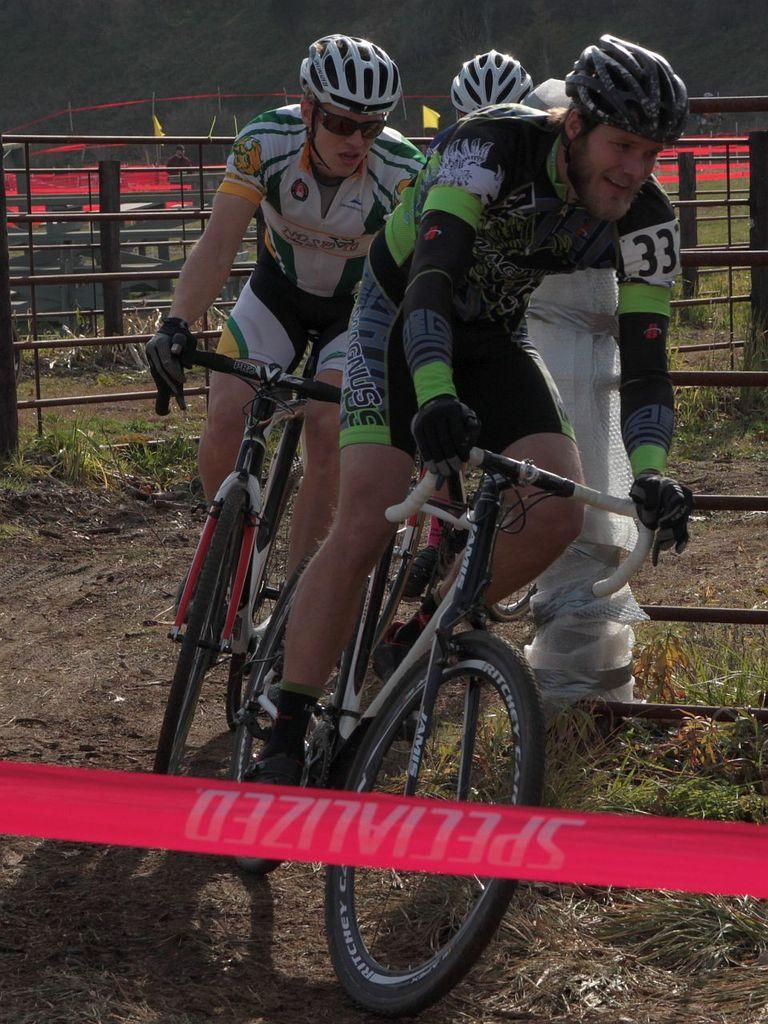What are the persons in the image doing? The persons in the image are riding bicycles. How are the bicycles positioned in the image? The bicycles are on the ground. What type of material can be seen in the image? Cloth is visible in the image. What architectural feature is present in the image? There is railing in the image. What can be seen in the background of the image? There is a fence in the background of the image, and the background is dark. What type of baseball equipment can be seen in the image? There is no baseball equipment present in the image. What type of farming tools can be seen in the image? There is no farming equipment present in the image. What type of furniture can be seen in the image? There is no furniture present in the image. 